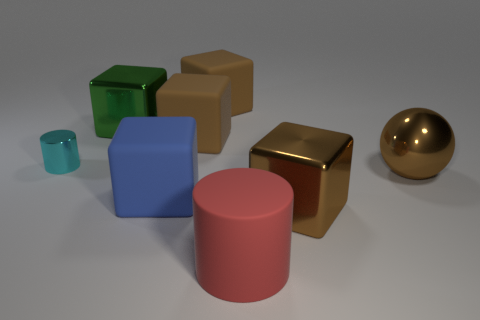Subtract all cyan cylinders. How many brown cubes are left? 3 Subtract all blue blocks. How many blocks are left? 4 Subtract all big green shiny blocks. How many blocks are left? 4 Subtract 2 blocks. How many blocks are left? 3 Subtract all yellow blocks. Subtract all red cylinders. How many blocks are left? 5 Add 2 purple metallic cubes. How many objects exist? 10 Subtract all cylinders. How many objects are left? 6 Subtract all small red metallic cylinders. Subtract all tiny objects. How many objects are left? 7 Add 3 large green metal objects. How many large green metal objects are left? 4 Add 8 brown metal spheres. How many brown metal spheres exist? 9 